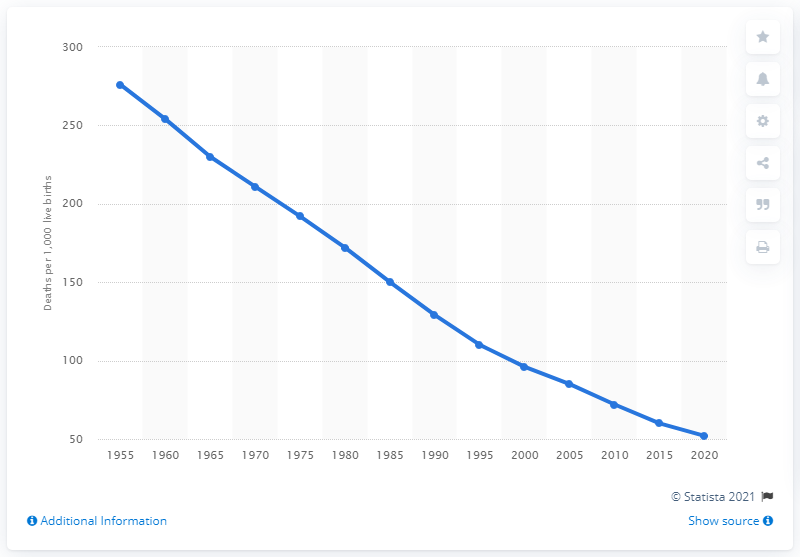Mention a couple of crucial points in this snapshot. In 1955, Afghanistan's infant mortality rate per thousand live births was 276. 